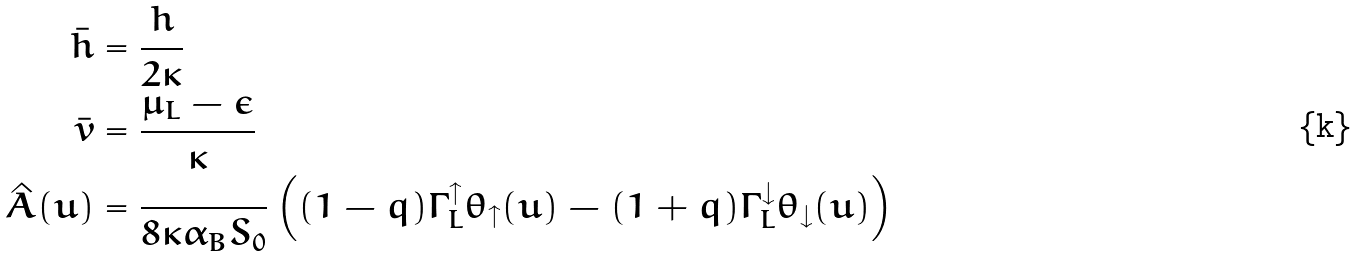Convert formula to latex. <formula><loc_0><loc_0><loc_500><loc_500>\bar { h } & = \frac { h } { 2 \kappa } \\ \bar { v } & = \frac { \mu _ { L } - \epsilon } { \kappa } \\ \hat { A } ( u ) & = \frac { } { 8 \kappa \alpha _ { B } S _ { 0 } } \left ( ( 1 - q ) \Gamma _ { L } ^ { \uparrow } \theta _ { \uparrow } ( u ) - ( 1 + q ) \Gamma _ { L } ^ { \downarrow } \theta _ { \downarrow } ( u ) \right )</formula> 